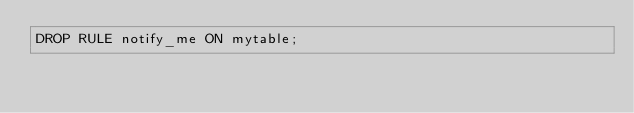<code> <loc_0><loc_0><loc_500><loc_500><_SQL_>DROP RULE notify_me ON mytable;
</code> 